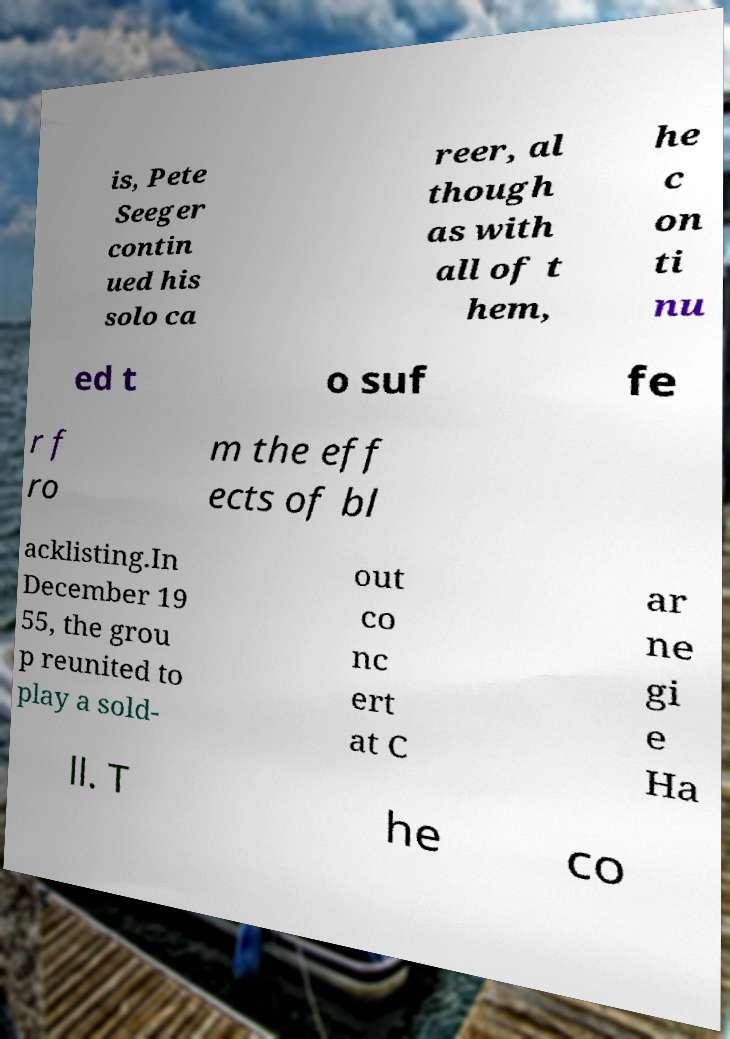Can you accurately transcribe the text from the provided image for me? is, Pete Seeger contin ued his solo ca reer, al though as with all of t hem, he c on ti nu ed t o suf fe r f ro m the eff ects of bl acklisting.In December 19 55, the grou p reunited to play a sold- out co nc ert at C ar ne gi e Ha ll. T he co 